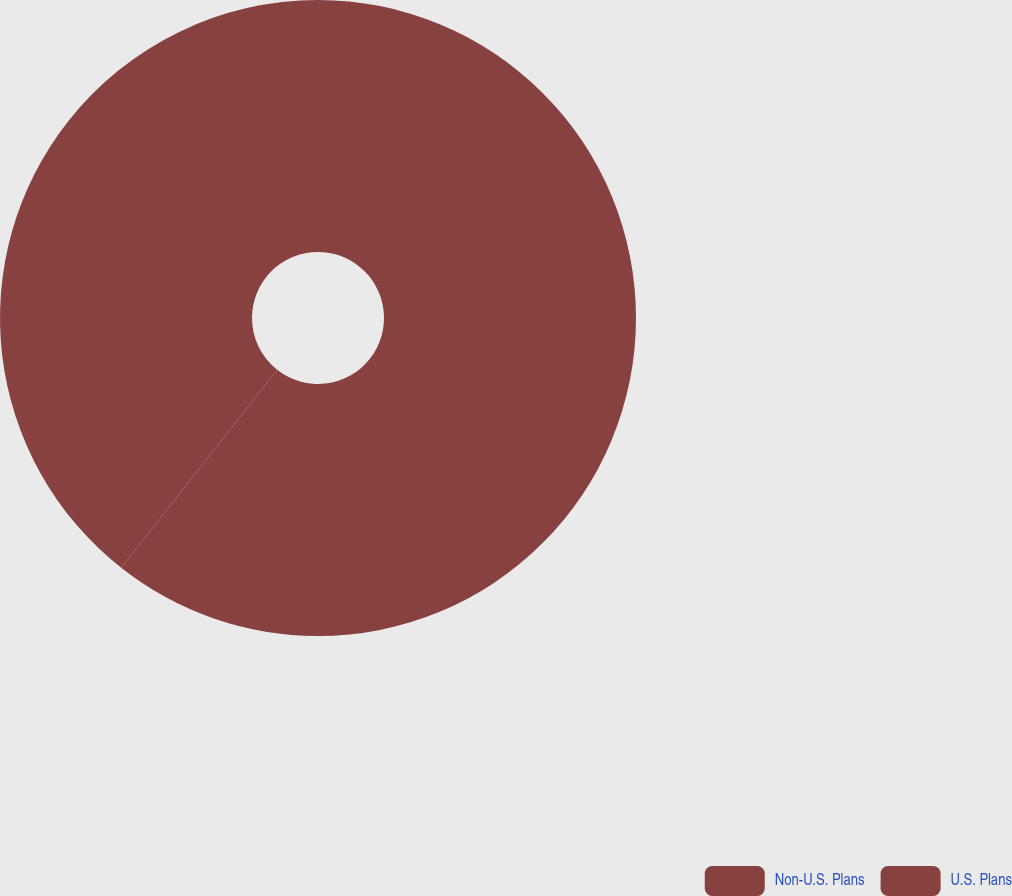<chart> <loc_0><loc_0><loc_500><loc_500><pie_chart><fcel>Non-U.S. Plans<fcel>U.S. Plans<nl><fcel>60.62%<fcel>39.38%<nl></chart> 